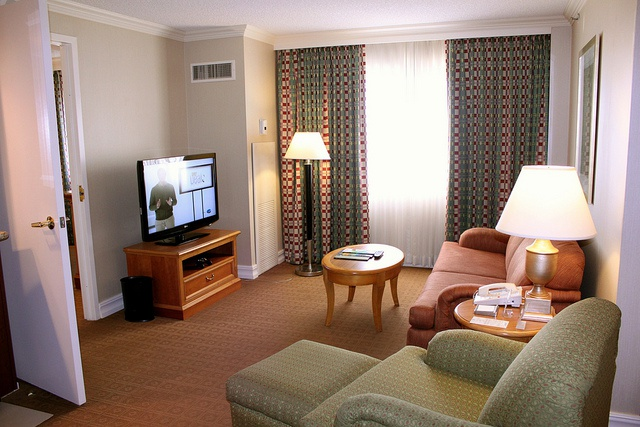Describe the objects in this image and their specific colors. I can see chair in gray tones, couch in gray tones, couch in gray, maroon, lightpink, brown, and salmon tones, tv in gray, lavender, and black tones, and dining table in gray, maroon, white, and brown tones in this image. 